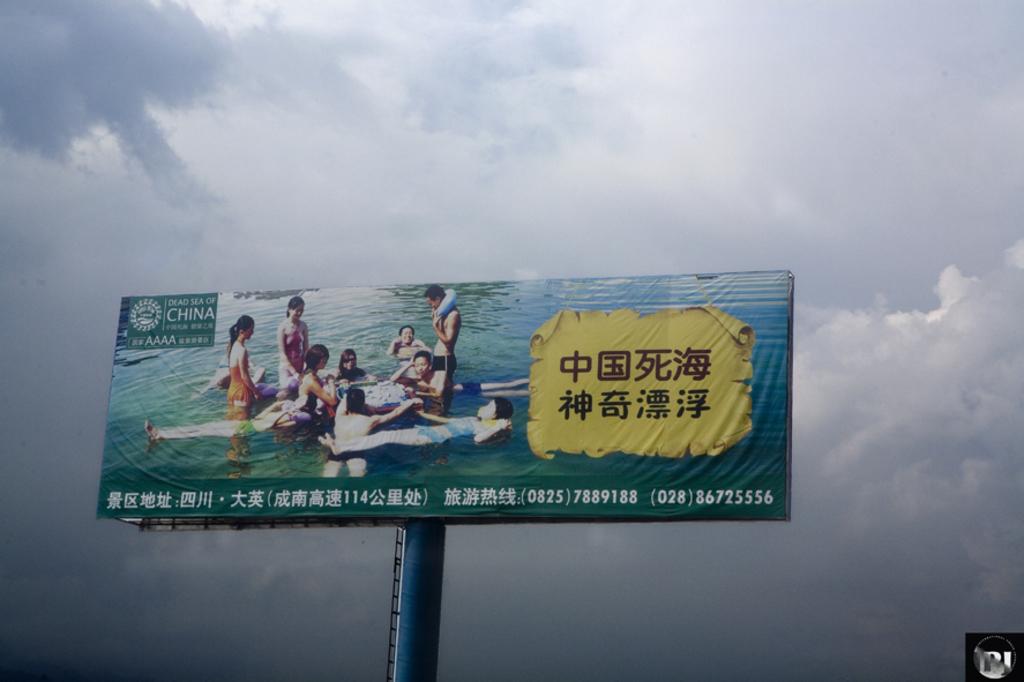What sea is in the photo?
Keep it short and to the point. Unanswerable. 